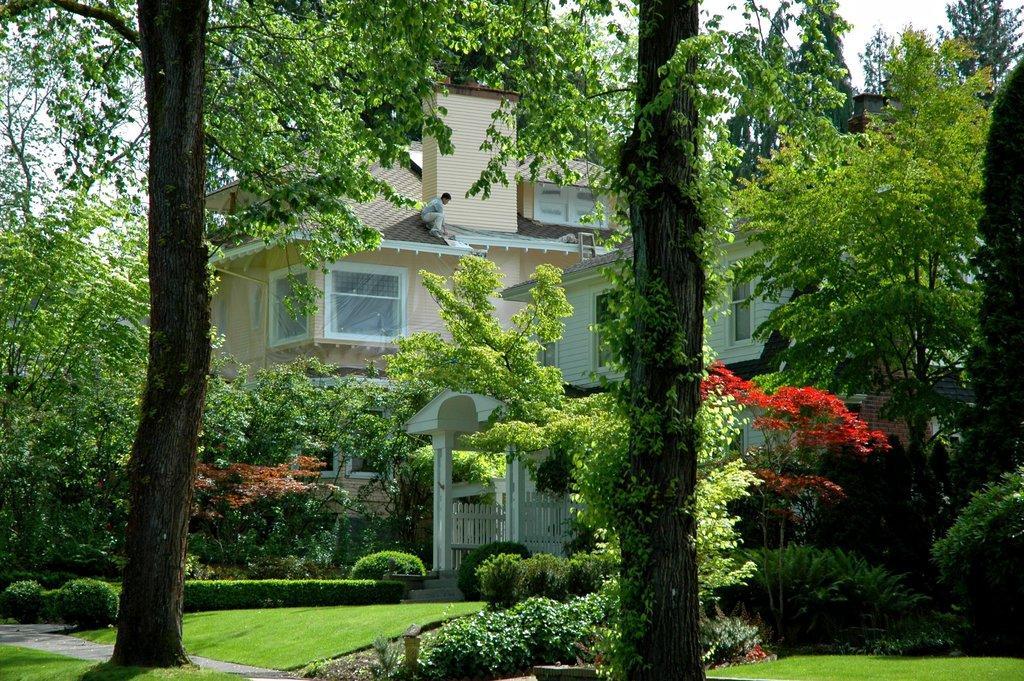Describe this image in one or two sentences. In the center of the image there are trees. In the background of the image there is house. At the bottom of the image there is grass. 